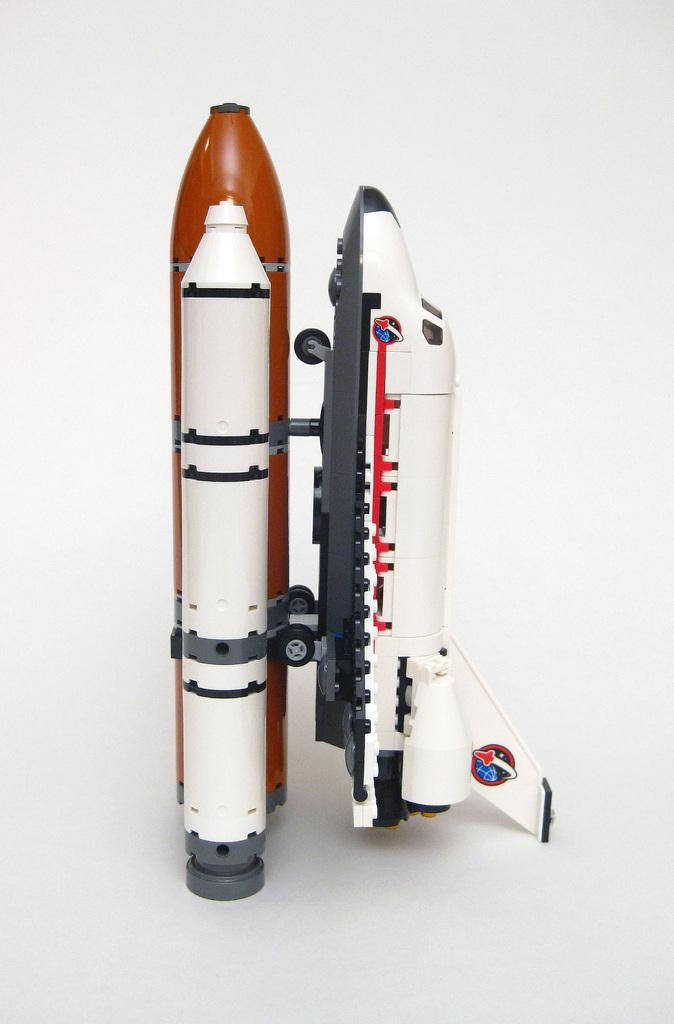What type of vehicle is shown in the image? The image depicts an artificial Space Plane. Where is the Space Plane located in the image? The Space Plane is on a launch pad. What feature of the Space Plane is mentioned in the facts? The Space Plane has wheels attached to it. What can be observed about the background of the image? The background appears white in color. How many toes can be seen on the Space Plane in the image? There are no toes present in the image, as it features an artificial Space Plane on a launch pad. What type of twig is used to steer the Space Plane in the image? There is no twig present in the image, and the Space Plane does not require a twig for steering. 